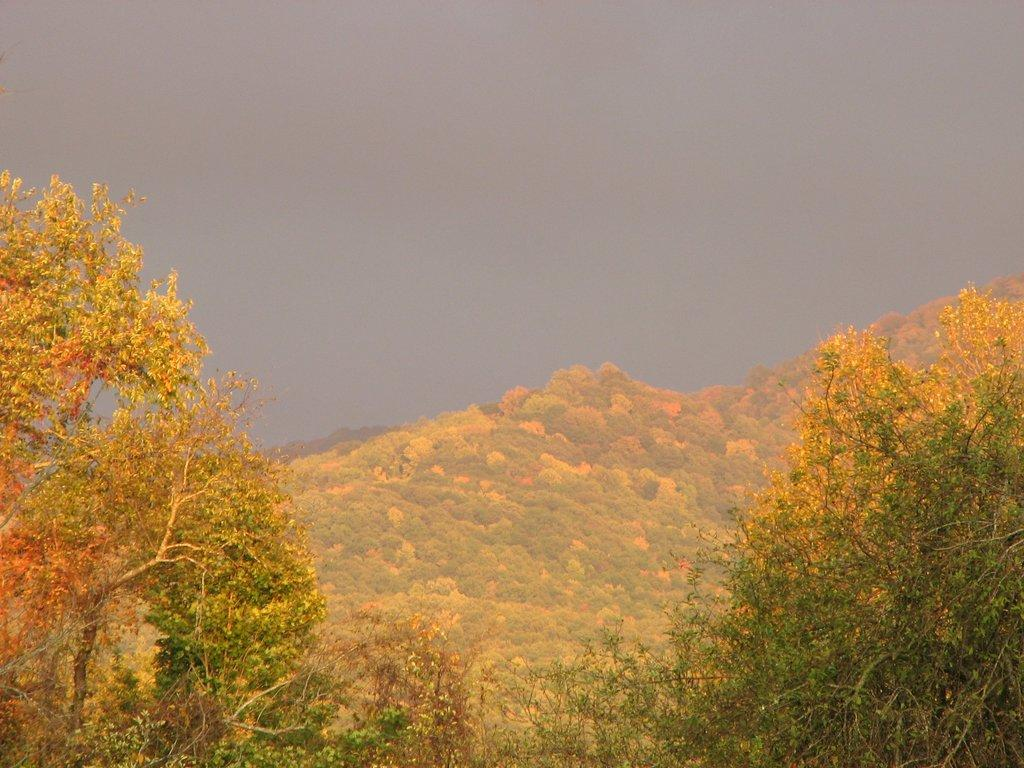What type of vegetation can be seen in the image? There are trees in the image. Can you describe the background of the image? There is a hill with trees in the background of the image. What is visible at the top of the image? The sky is visible at the top of the image. Where is the throne located in the image? There is no throne present in the image. How many toy cars can be seen on the hill in the background? There are no toy cars present in the image. 